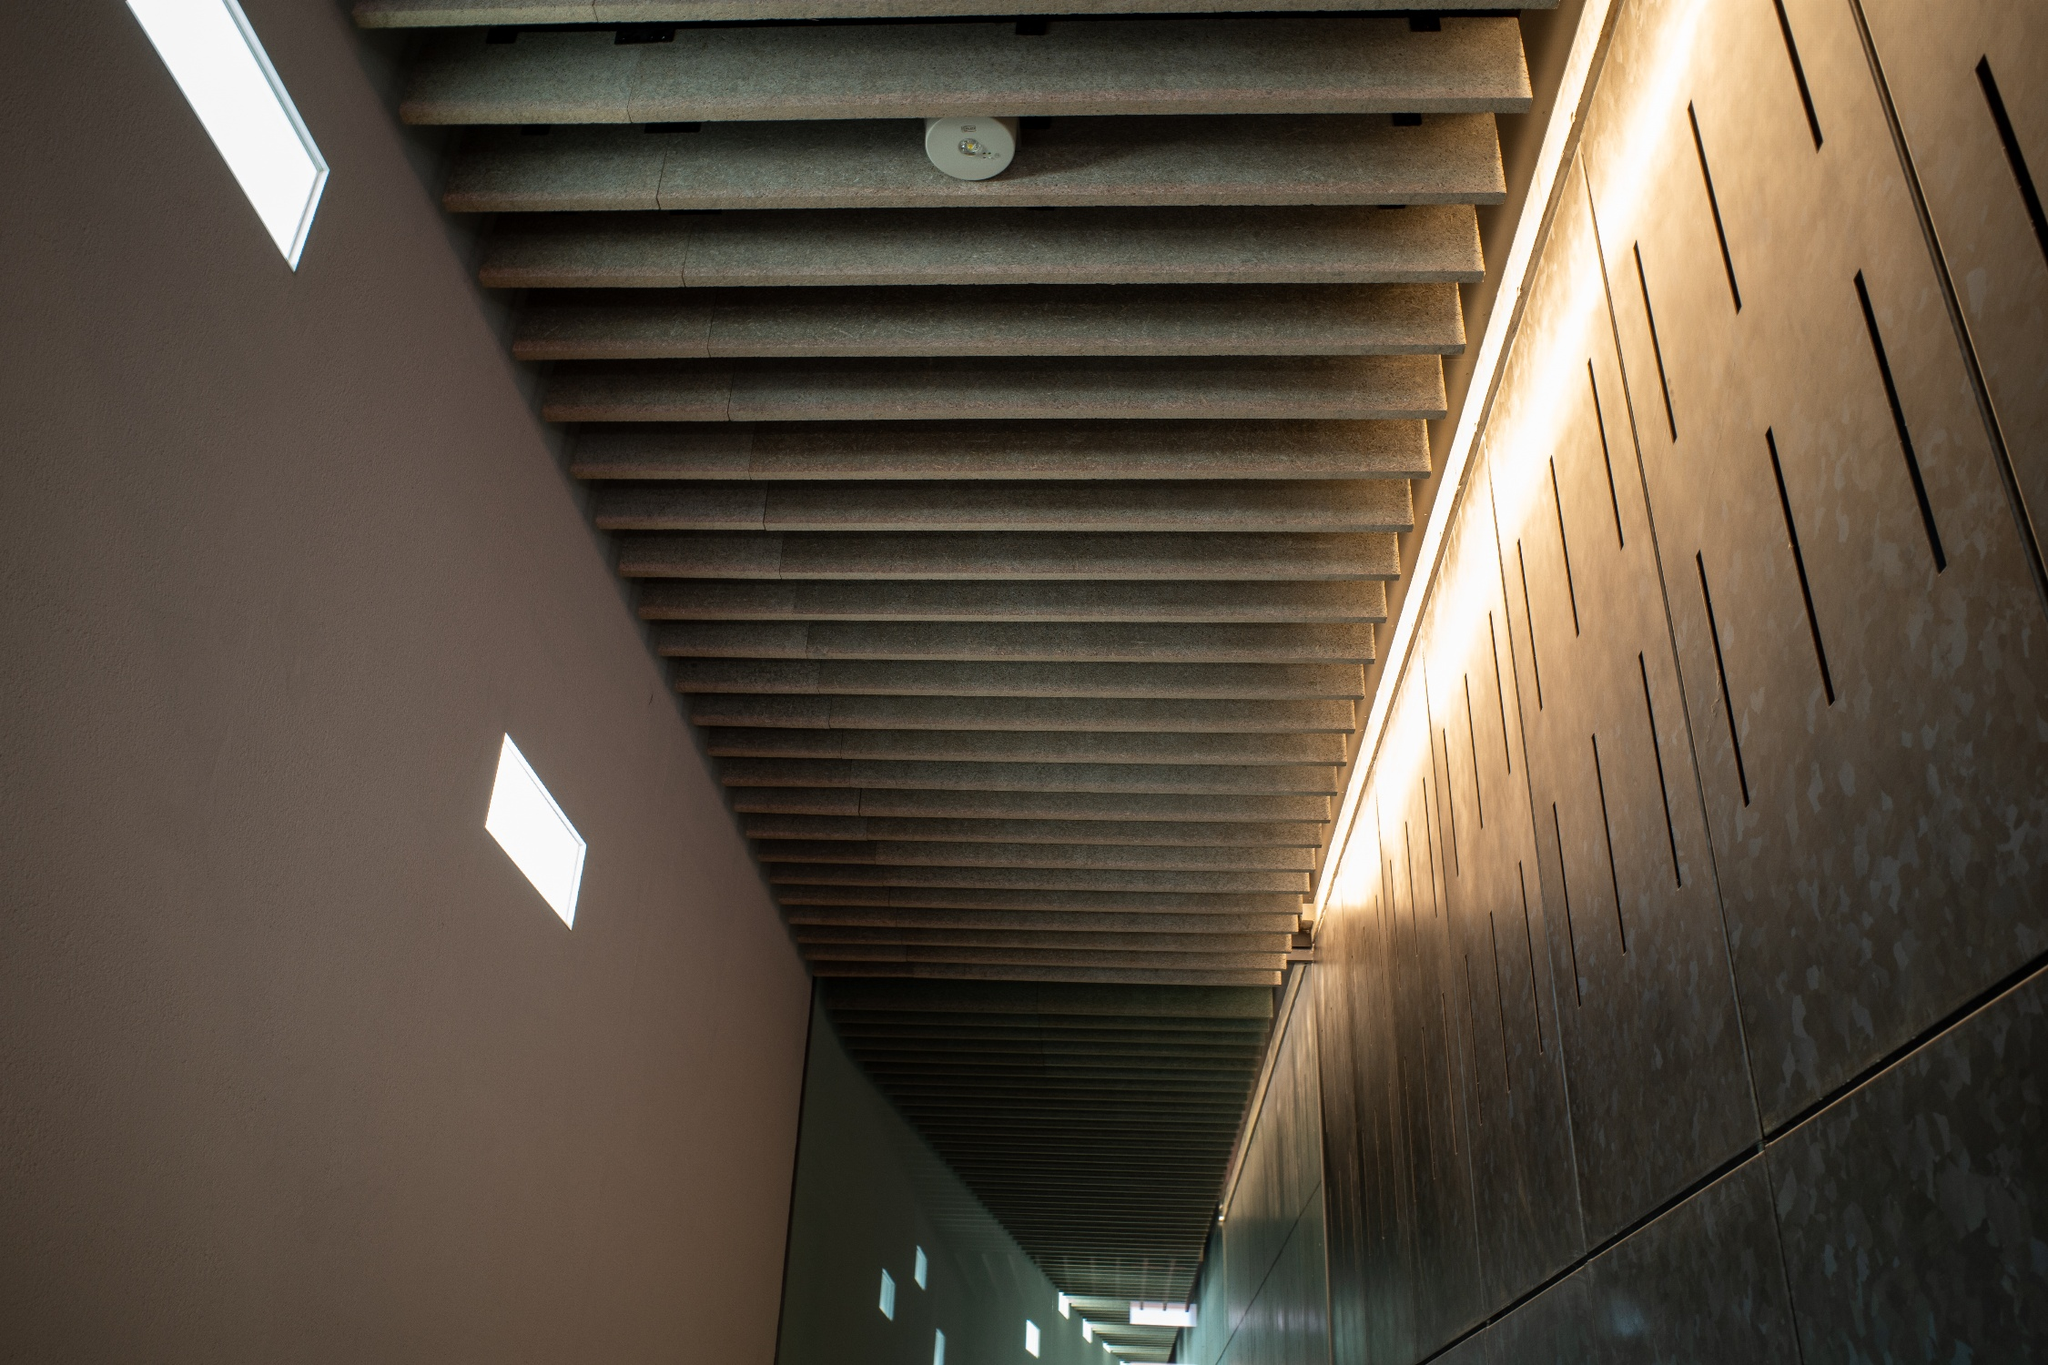Can you provide a creative story inspired by this hallway? In a futuristic society, this hallway is the main passage within the AI headquarters, where synthetic beings and advanced humans collaborate to maintain the harmony of their technologically advanced cities. The ambient lights softly pulse with each step, responding to the energy of those who pass through. Legends say that somewhere within this endless corridor lies a hidden door leading to an ancient archive, holding secrets of the world's transition from chaos to order. 